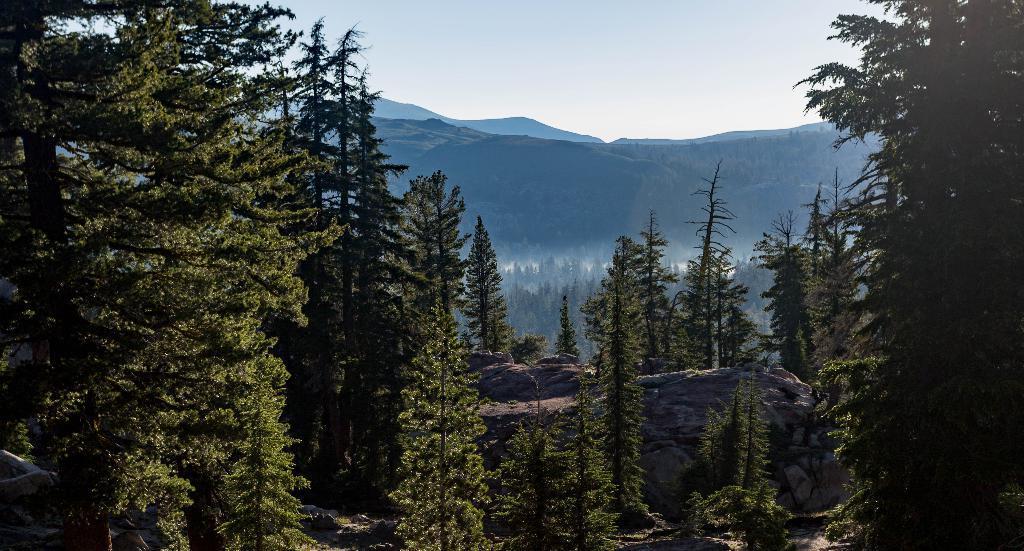Can you describe this image briefly? In this image we can see few mountains. There are many trees in the image. We can see the sky in the image. There is a rock in the image. 